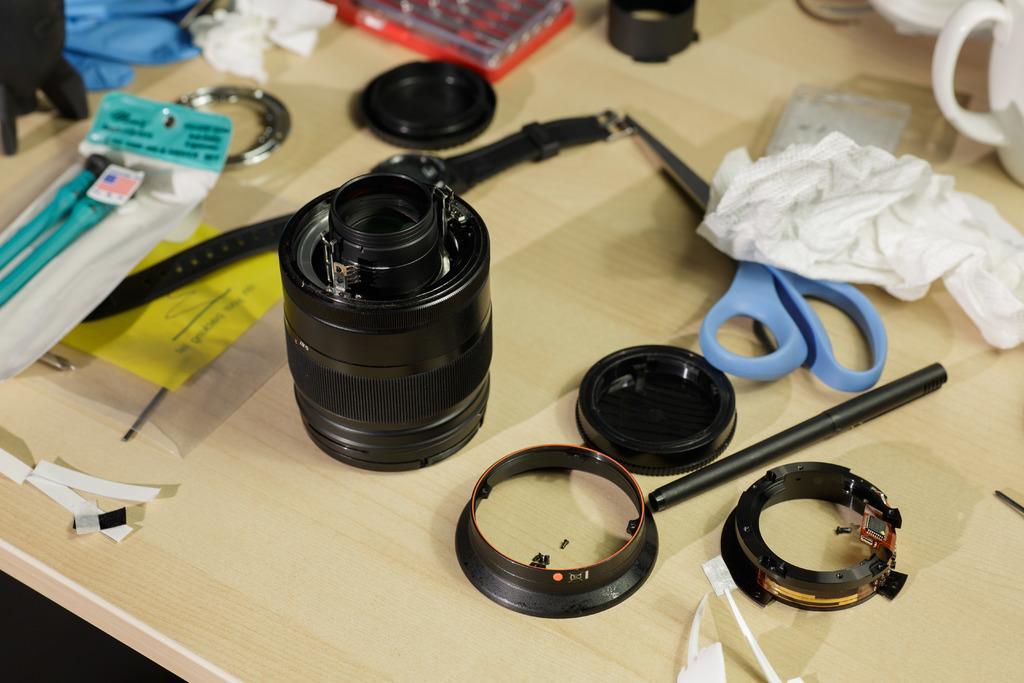Please provide a concise description of this image. In this picture, we see a wooden table on which lens of the camera, pen, scissors, tissue paper, watch, plastic cover, cups, clothes in white and blue color and some objects are placed. 